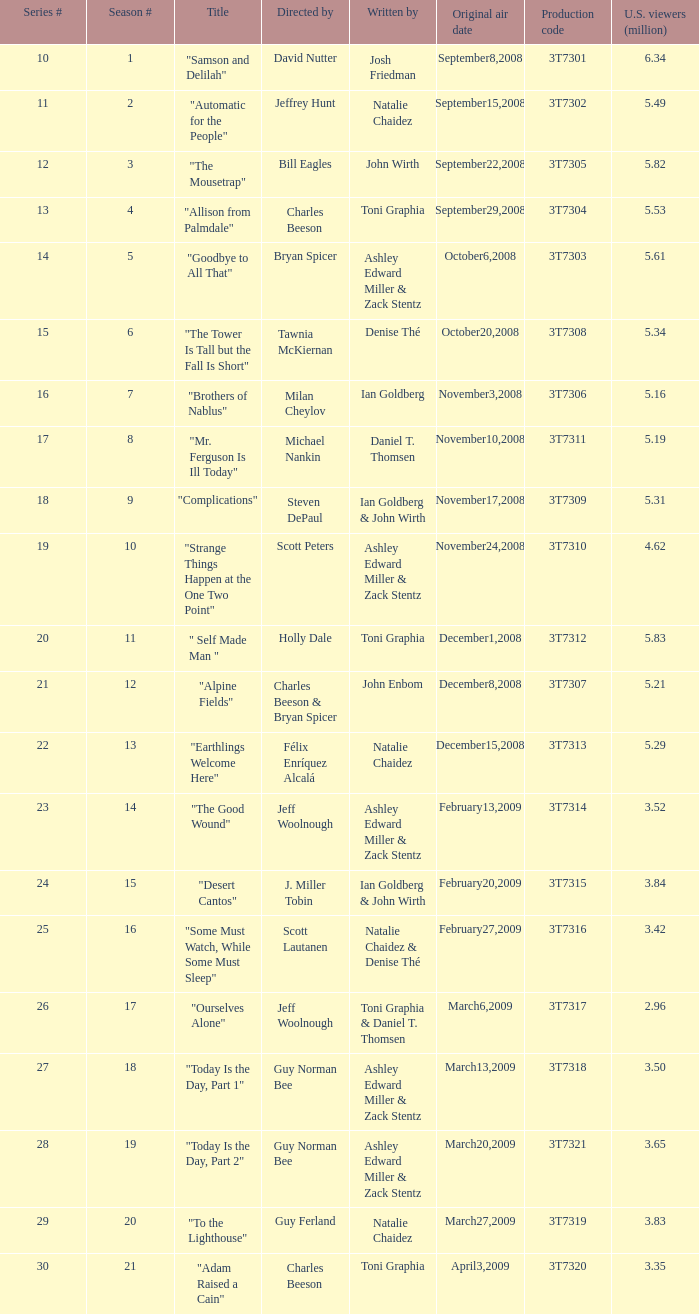Which episode number pulled in 1.0. Would you mind parsing the complete table? {'header': ['Series #', 'Season #', 'Title', 'Directed by', 'Written by', 'Original air date', 'Production code', 'U.S. viewers (million)'], 'rows': [['10', '1', '"Samson and Delilah"', 'David Nutter', 'Josh Friedman', 'September8,2008', '3T7301', '6.34'], ['11', '2', '"Automatic for the People"', 'Jeffrey Hunt', 'Natalie Chaidez', 'September15,2008', '3T7302', '5.49'], ['12', '3', '"The Mousetrap"', 'Bill Eagles', 'John Wirth', 'September22,2008', '3T7305', '5.82'], ['13', '4', '"Allison from Palmdale"', 'Charles Beeson', 'Toni Graphia', 'September29,2008', '3T7304', '5.53'], ['14', '5', '"Goodbye to All That"', 'Bryan Spicer', 'Ashley Edward Miller & Zack Stentz', 'October6,2008', '3T7303', '5.61'], ['15', '6', '"The Tower Is Tall but the Fall Is Short"', 'Tawnia McKiernan', 'Denise Thé', 'October20,2008', '3T7308', '5.34'], ['16', '7', '"Brothers of Nablus"', 'Milan Cheylov', 'Ian Goldberg', 'November3,2008', '3T7306', '5.16'], ['17', '8', '"Mr. Ferguson Is Ill Today"', 'Michael Nankin', 'Daniel T. Thomsen', 'November10,2008', '3T7311', '5.19'], ['18', '9', '"Complications"', 'Steven DePaul', 'Ian Goldberg & John Wirth', 'November17,2008', '3T7309', '5.31'], ['19', '10', '"Strange Things Happen at the One Two Point"', 'Scott Peters', 'Ashley Edward Miller & Zack Stentz', 'November24,2008', '3T7310', '4.62'], ['20', '11', '" Self Made Man "', 'Holly Dale', 'Toni Graphia', 'December1,2008', '3T7312', '5.83'], ['21', '12', '"Alpine Fields"', 'Charles Beeson & Bryan Spicer', 'John Enbom', 'December8,2008', '3T7307', '5.21'], ['22', '13', '"Earthlings Welcome Here"', 'Félix Enríquez Alcalá', 'Natalie Chaidez', 'December15,2008', '3T7313', '5.29'], ['23', '14', '"The Good Wound"', 'Jeff Woolnough', 'Ashley Edward Miller & Zack Stentz', 'February13,2009', '3T7314', '3.52'], ['24', '15', '"Desert Cantos"', 'J. Miller Tobin', 'Ian Goldberg & John Wirth', 'February20,2009', '3T7315', '3.84'], ['25', '16', '"Some Must Watch, While Some Must Sleep"', 'Scott Lautanen', 'Natalie Chaidez & Denise Thé', 'February27,2009', '3T7316', '3.42'], ['26', '17', '"Ourselves Alone"', 'Jeff Woolnough', 'Toni Graphia & Daniel T. Thomsen', 'March6,2009', '3T7317', '2.96'], ['27', '18', '"Today Is the Day, Part 1"', 'Guy Norman Bee', 'Ashley Edward Miller & Zack Stentz', 'March13,2009', '3T7318', '3.50'], ['28', '19', '"Today Is the Day, Part 2"', 'Guy Norman Bee', 'Ashley Edward Miller & Zack Stentz', 'March20,2009', '3T7321', '3.65'], ['29', '20', '"To the Lighthouse"', 'Guy Ferland', 'Natalie Chaidez', 'March27,2009', '3T7319', '3.83'], ['30', '21', '"Adam Raised a Cain"', 'Charles Beeson', 'Toni Graphia', 'April3,2009', '3T7320', '3.35']]} 